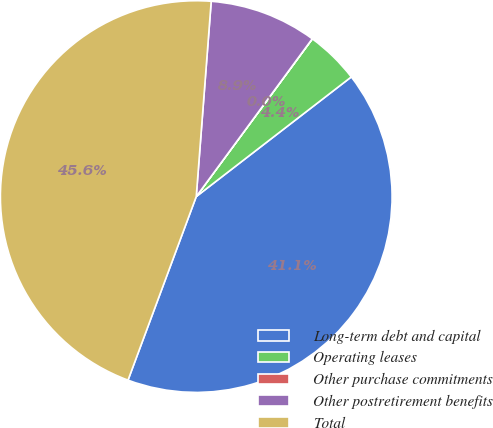Convert chart. <chart><loc_0><loc_0><loc_500><loc_500><pie_chart><fcel>Long-term debt and capital<fcel>Operating leases<fcel>Other purchase commitments<fcel>Other postretirement benefits<fcel>Total<nl><fcel>41.12%<fcel>4.44%<fcel>0.01%<fcel>8.87%<fcel>45.55%<nl></chart> 